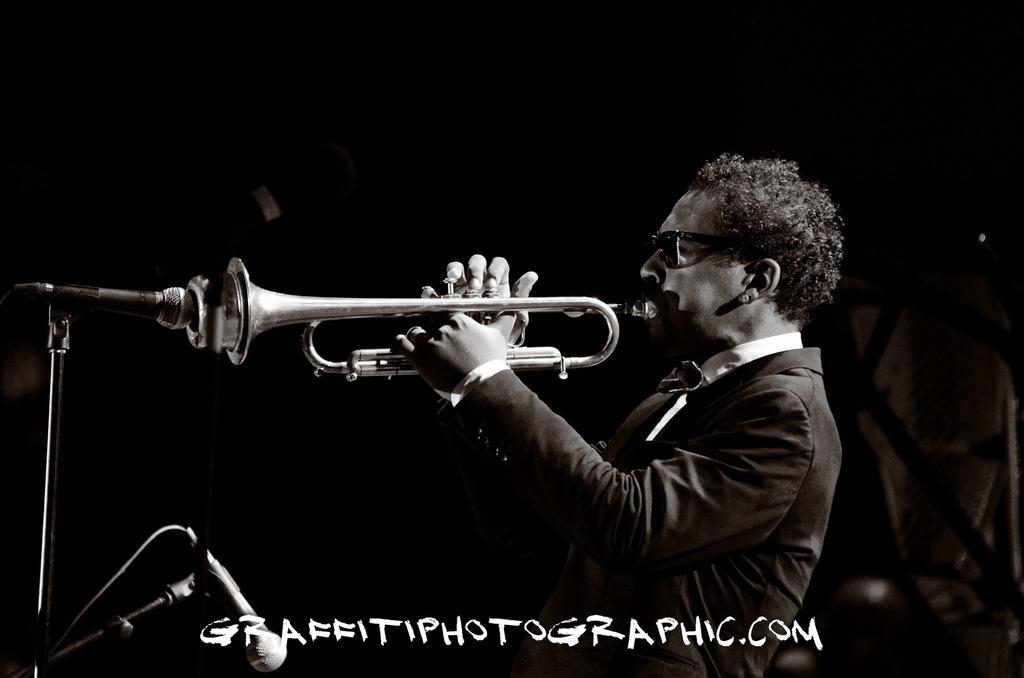Could you give a brief overview of what you see in this image? In this picture we can see a man wore a blazer, goggles and holding a trumpet with his hands and in front of him we can see mics and in the background we can see some objects and it is dark. 